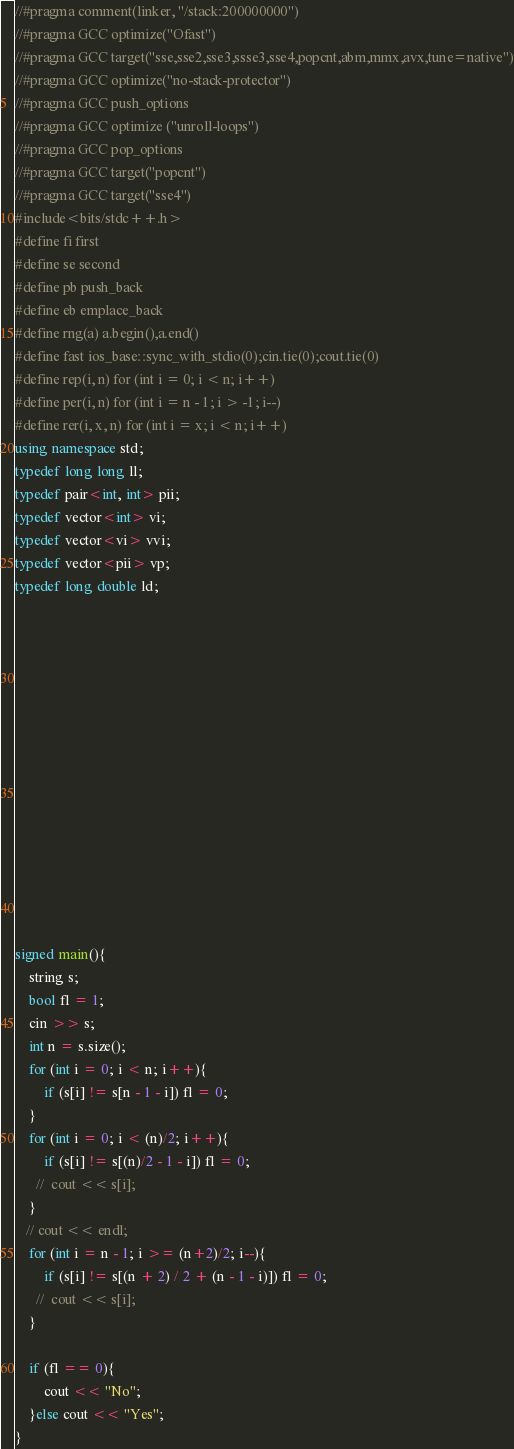<code> <loc_0><loc_0><loc_500><loc_500><_C++_>//#pragma comment(linker, "/stack:200000000")
//#pragma GCC optimize("Ofast")
//#pragma GCC target("sse,sse2,sse3,ssse3,sse4,popcnt,abm,mmx,avx,tune=native")
//#pragma GCC optimize("no-stack-protector")
//#pragma GCC push_options
//#pragma GCC optimize ("unroll-loops")
//#pragma GCC pop_options
//#pragma GCC target("popcnt")
//#pragma GCC target("sse4")
#include<bits/stdc++.h>
#define fi first
#define se second
#define pb push_back
#define eb emplace_back
#define rng(a) a.begin(),a.end()
#define fast ios_base::sync_with_stdio(0);cin.tie(0);cout.tie(0)
#define rep(i, n) for (int i = 0; i < n; i++)
#define per(i, n) for (int i = n - 1; i > -1; i--)
#define rer(i, x, n) for (int i = x; i < n; i++)
using namespace std;
typedef long long ll;
typedef pair<int, int> pii;
typedef vector<int> vi;
typedef vector<vi> vvi;
typedef vector<pii> vp;
typedef long double ld;















signed main(){
    string s;
    bool fl = 1;
    cin >> s;
    int n = s.size();
    for (int i = 0; i < n; i++){
        if (s[i] != s[n - 1 - i]) fl = 0;
    }
    for (int i = 0; i < (n)/2; i++){
        if (s[i] != s[(n)/2 - 1 - i]) fl = 0;
      //  cout << s[i];
    }
   // cout << endl;
    for (int i = n - 1; i >= (n+2)/2; i--){
        if (s[i] != s[(n + 2) / 2 + (n - 1 - i)]) fl = 0;
      //  cout << s[i];
    }

    if (fl == 0){
        cout << "No";
    }else cout << "Yes";
}
</code> 